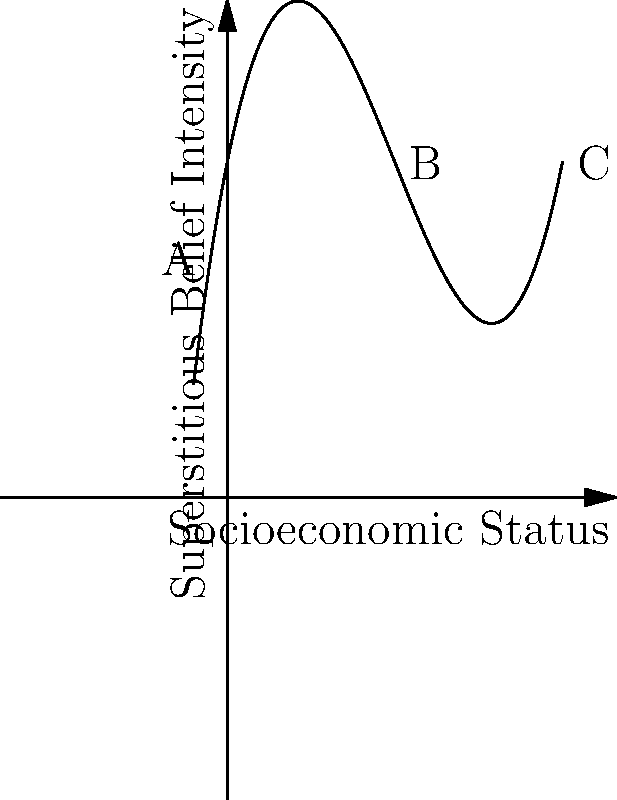The graph above represents the relationship between socioeconomic status (x-axis) and the intensity of superstitious beliefs (y-axis) in a particular culture. Based on the shape of the curve, what can be inferred about the correlation between these factors at different socioeconomic levels? Focus on the behavior of the curve at points A, B, and C. To analyze the correlation between superstitious beliefs and socioeconomic factors, let's examine the curve at different points:

1. Point A (low socioeconomic status):
   - The curve has a positive slope, indicating a positive correlation.
   - This suggests that as socioeconomic status initially increases, superstitious beliefs also increase.

2. Point B (middle socioeconomic status):
   - The curve reaches its peak and begins to turn downward.
   - This indicates a change in the correlation from positive to negative.
   - It suggests that at this socioeconomic level, superstitious beliefs are at their highest.

3. Point C (high socioeconomic status):
   - The curve has a negative slope, indicating a negative correlation.
   - This implies that as socioeconomic status continues to increase, superstitious beliefs decrease.

4. Overall shape:
   - The polynomial curve forms an inverted U-shape.
   - This suggests a non-linear relationship between socioeconomic status and superstitious beliefs.

5. Cultural interpretation:
   - The curve implies that superstitious beliefs are most prevalent in the middle socioeconomic class.
   - Lower and higher socioeconomic classes show lower levels of superstitious beliefs, but for potentially different reasons.

6. Possible explanations:
   - Lower class: May be focused on immediate survival needs, with less time for superstitious practices.
   - Middle class: Might have more time and resources to engage in cultural practices, including superstitions.
   - Upper class: Might have access to better education and scientific knowledge, potentially reducing superstitious beliefs.
Answer: Non-linear relationship: positive correlation at low socioeconomic levels, peaks at middle levels, negative correlation at high levels. 